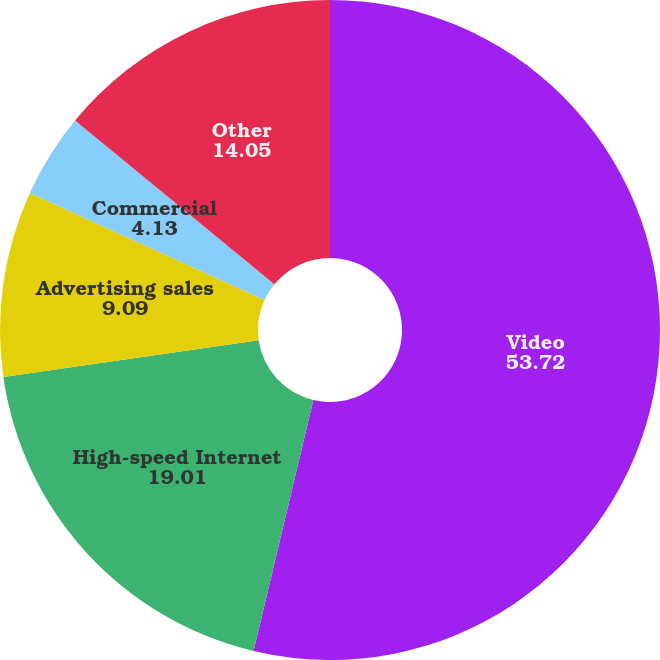<chart> <loc_0><loc_0><loc_500><loc_500><pie_chart><fcel>Video<fcel>High-speed Internet<fcel>Advertising sales<fcel>Commercial<fcel>Other<nl><fcel>53.72%<fcel>19.01%<fcel>9.09%<fcel>4.13%<fcel>14.05%<nl></chart> 